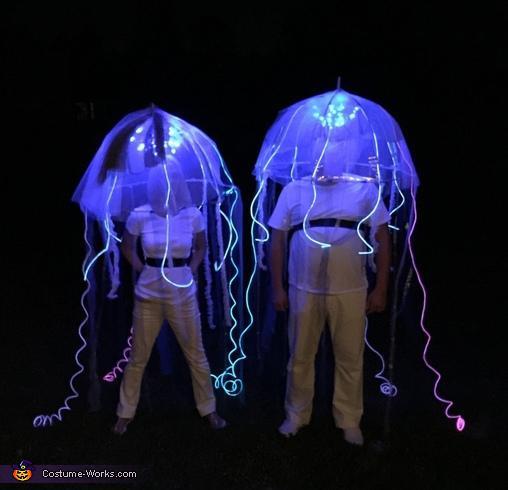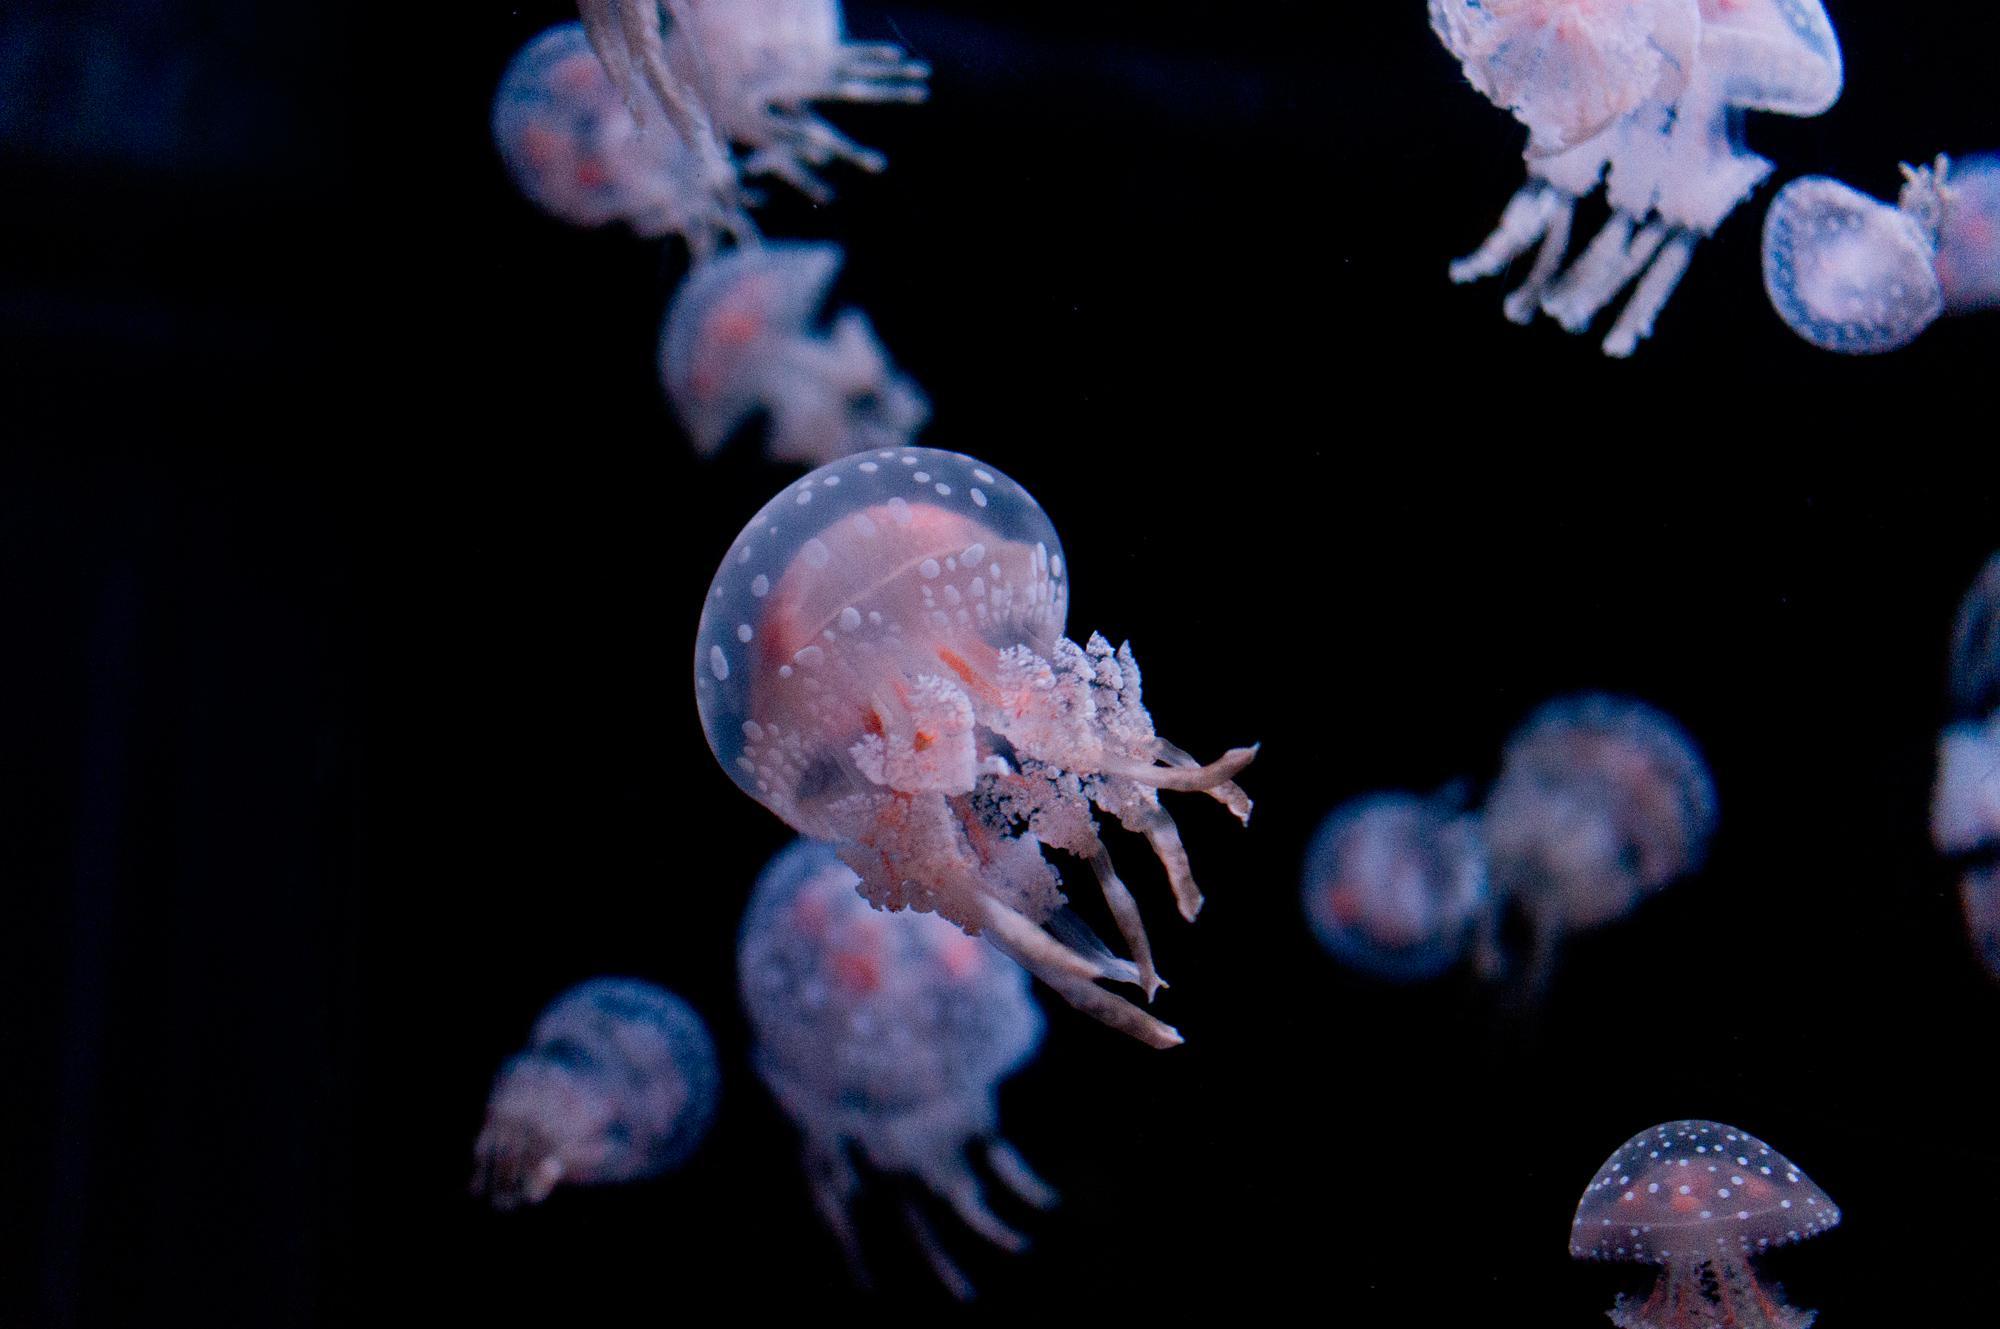The first image is the image on the left, the second image is the image on the right. For the images shown, is this caption "There are no more than five jellyfish in the image on the left" true? Answer yes or no. Yes. 